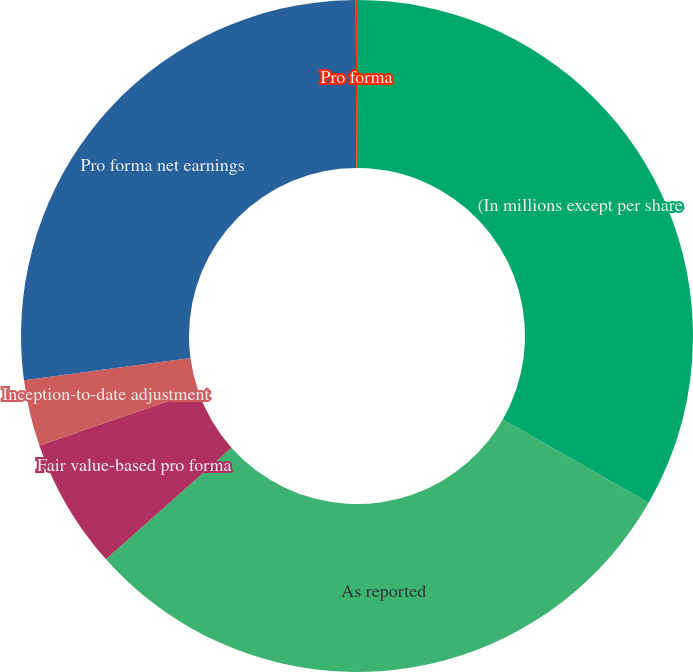<chart> <loc_0><loc_0><loc_500><loc_500><pie_chart><fcel>(In millions except per share<fcel>As reported<fcel>Fair value-based pro forma<fcel>Inception-to-date adjustment<fcel>Pro forma net earnings<fcel>Pro forma<nl><fcel>33.27%<fcel>30.16%<fcel>6.29%<fcel>3.18%<fcel>27.04%<fcel>0.06%<nl></chart> 